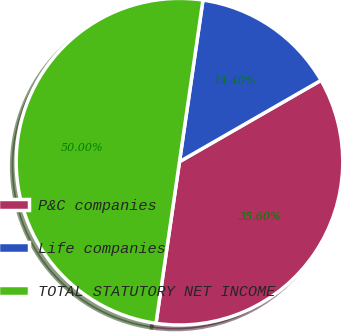Convert chart. <chart><loc_0><loc_0><loc_500><loc_500><pie_chart><fcel>P&C companies<fcel>Life companies<fcel>TOTAL STATUTORY NET INCOME<nl><fcel>35.6%<fcel>14.4%<fcel>50.0%<nl></chart> 